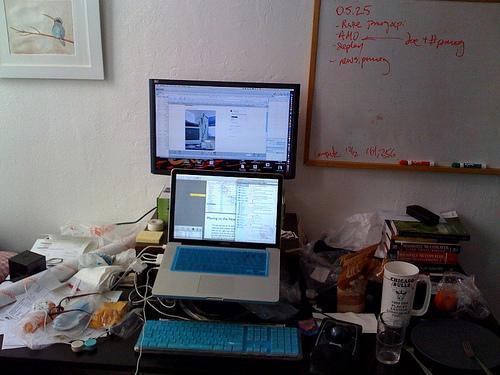How many computers can be seen?
Give a very brief answer. 2. How many horses are there?
Give a very brief answer. 0. 